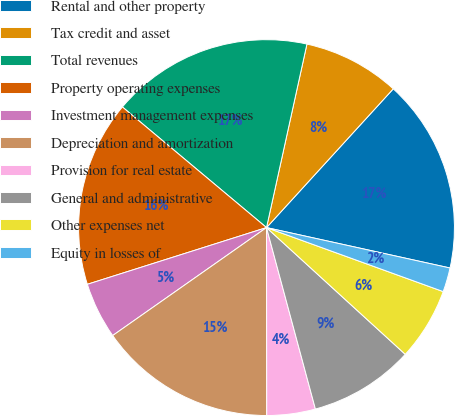Convert chart to OTSL. <chart><loc_0><loc_0><loc_500><loc_500><pie_chart><fcel>Rental and other property<fcel>Tax credit and asset<fcel>Total revenues<fcel>Property operating expenses<fcel>Investment management expenses<fcel>Depreciation and amortization<fcel>Provision for real estate<fcel>General and administrative<fcel>Other expenses net<fcel>Equity in losses of<nl><fcel>16.67%<fcel>8.33%<fcel>17.36%<fcel>15.97%<fcel>4.86%<fcel>15.28%<fcel>4.17%<fcel>9.03%<fcel>6.25%<fcel>2.08%<nl></chart> 